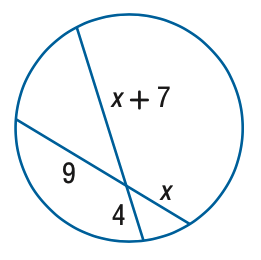Question: Find x.
Choices:
A. 4.6
B. 5.6
C. 6.6
D. 7.6
Answer with the letter. Answer: B 